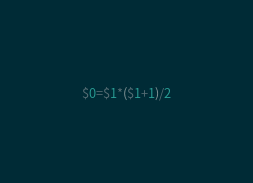Convert code to text. <code><loc_0><loc_0><loc_500><loc_500><_Awk_>$0=$1*($1+1)/2</code> 